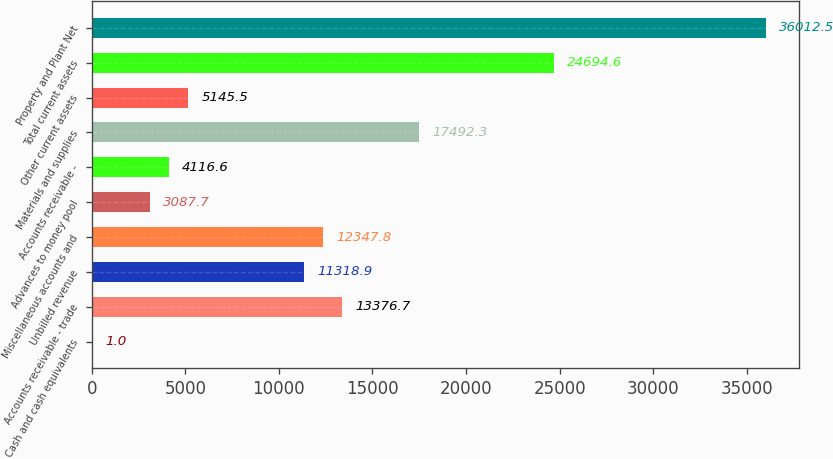<chart> <loc_0><loc_0><loc_500><loc_500><bar_chart><fcel>Cash and cash equivalents<fcel>Accounts receivable - trade<fcel>Unbilled revenue<fcel>Miscellaneous accounts and<fcel>Advances to money pool<fcel>Accounts receivable -<fcel>Materials and supplies<fcel>Other current assets<fcel>Total current assets<fcel>Property and Plant Net<nl><fcel>1<fcel>13376.7<fcel>11318.9<fcel>12347.8<fcel>3087.7<fcel>4116.6<fcel>17492.3<fcel>5145.5<fcel>24694.6<fcel>36012.5<nl></chart> 